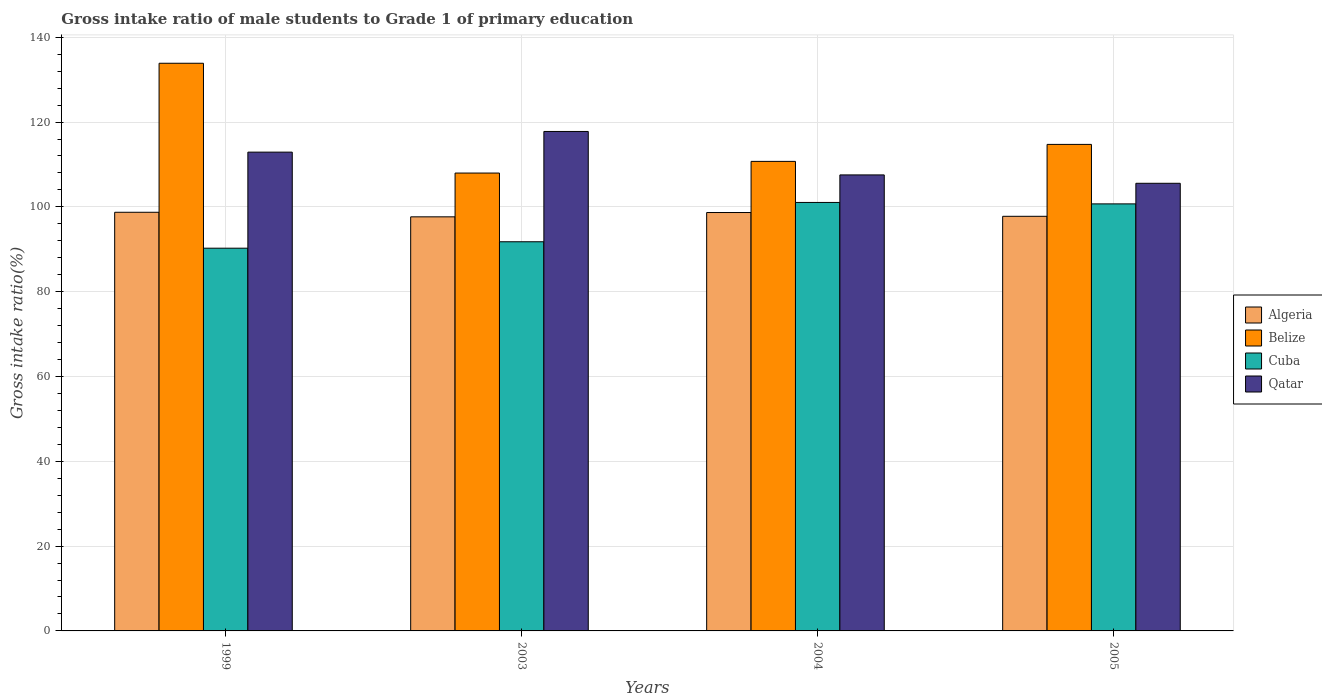Are the number of bars per tick equal to the number of legend labels?
Provide a short and direct response. Yes. Are the number of bars on each tick of the X-axis equal?
Provide a short and direct response. Yes. How many bars are there on the 3rd tick from the right?
Offer a very short reply. 4. In how many cases, is the number of bars for a given year not equal to the number of legend labels?
Your answer should be very brief. 0. What is the gross intake ratio in Belize in 2005?
Your answer should be compact. 114.73. Across all years, what is the maximum gross intake ratio in Cuba?
Offer a terse response. 101.04. Across all years, what is the minimum gross intake ratio in Qatar?
Offer a very short reply. 105.56. In which year was the gross intake ratio in Qatar minimum?
Offer a terse response. 2005. What is the total gross intake ratio in Algeria in the graph?
Make the answer very short. 392.81. What is the difference between the gross intake ratio in Qatar in 1999 and that in 2005?
Your response must be concise. 7.35. What is the difference between the gross intake ratio in Belize in 2003 and the gross intake ratio in Cuba in 2005?
Make the answer very short. 7.27. What is the average gross intake ratio in Belize per year?
Your answer should be very brief. 116.82. In the year 2004, what is the difference between the gross intake ratio in Belize and gross intake ratio in Qatar?
Your answer should be compact. 3.19. What is the ratio of the gross intake ratio in Qatar in 1999 to that in 2005?
Your answer should be compact. 1.07. Is the difference between the gross intake ratio in Belize in 1999 and 2004 greater than the difference between the gross intake ratio in Qatar in 1999 and 2004?
Your response must be concise. Yes. What is the difference between the highest and the second highest gross intake ratio in Cuba?
Make the answer very short. 0.34. What is the difference between the highest and the lowest gross intake ratio in Algeria?
Your answer should be very brief. 1.08. In how many years, is the gross intake ratio in Cuba greater than the average gross intake ratio in Cuba taken over all years?
Offer a terse response. 2. What does the 1st bar from the left in 2004 represents?
Your answer should be very brief. Algeria. What does the 4th bar from the right in 2003 represents?
Ensure brevity in your answer.  Algeria. How many bars are there?
Your response must be concise. 16. Are all the bars in the graph horizontal?
Provide a short and direct response. No. How many years are there in the graph?
Give a very brief answer. 4. What is the difference between two consecutive major ticks on the Y-axis?
Your answer should be compact. 20. Are the values on the major ticks of Y-axis written in scientific E-notation?
Give a very brief answer. No. Does the graph contain grids?
Give a very brief answer. Yes. What is the title of the graph?
Ensure brevity in your answer.  Gross intake ratio of male students to Grade 1 of primary education. What is the label or title of the Y-axis?
Your answer should be very brief. Gross intake ratio(%). What is the Gross intake ratio(%) of Algeria in 1999?
Keep it short and to the point. 98.72. What is the Gross intake ratio(%) in Belize in 1999?
Offer a terse response. 133.86. What is the Gross intake ratio(%) in Cuba in 1999?
Your answer should be very brief. 90.25. What is the Gross intake ratio(%) in Qatar in 1999?
Give a very brief answer. 112.9. What is the Gross intake ratio(%) of Algeria in 2003?
Your response must be concise. 97.65. What is the Gross intake ratio(%) of Belize in 2003?
Ensure brevity in your answer.  107.97. What is the Gross intake ratio(%) of Cuba in 2003?
Your answer should be very brief. 91.77. What is the Gross intake ratio(%) in Qatar in 2003?
Keep it short and to the point. 117.78. What is the Gross intake ratio(%) in Algeria in 2004?
Provide a short and direct response. 98.66. What is the Gross intake ratio(%) of Belize in 2004?
Make the answer very short. 110.72. What is the Gross intake ratio(%) in Cuba in 2004?
Provide a short and direct response. 101.04. What is the Gross intake ratio(%) of Qatar in 2004?
Keep it short and to the point. 107.53. What is the Gross intake ratio(%) of Algeria in 2005?
Your response must be concise. 97.77. What is the Gross intake ratio(%) of Belize in 2005?
Offer a very short reply. 114.73. What is the Gross intake ratio(%) of Cuba in 2005?
Give a very brief answer. 100.7. What is the Gross intake ratio(%) in Qatar in 2005?
Offer a very short reply. 105.56. Across all years, what is the maximum Gross intake ratio(%) in Algeria?
Provide a succinct answer. 98.72. Across all years, what is the maximum Gross intake ratio(%) in Belize?
Offer a very short reply. 133.86. Across all years, what is the maximum Gross intake ratio(%) in Cuba?
Provide a short and direct response. 101.04. Across all years, what is the maximum Gross intake ratio(%) in Qatar?
Your answer should be very brief. 117.78. Across all years, what is the minimum Gross intake ratio(%) of Algeria?
Offer a terse response. 97.65. Across all years, what is the minimum Gross intake ratio(%) of Belize?
Give a very brief answer. 107.97. Across all years, what is the minimum Gross intake ratio(%) of Cuba?
Your answer should be very brief. 90.25. Across all years, what is the minimum Gross intake ratio(%) of Qatar?
Offer a terse response. 105.56. What is the total Gross intake ratio(%) of Algeria in the graph?
Keep it short and to the point. 392.81. What is the total Gross intake ratio(%) of Belize in the graph?
Provide a short and direct response. 467.29. What is the total Gross intake ratio(%) in Cuba in the graph?
Keep it short and to the point. 383.77. What is the total Gross intake ratio(%) of Qatar in the graph?
Give a very brief answer. 443.78. What is the difference between the Gross intake ratio(%) in Algeria in 1999 and that in 2003?
Offer a terse response. 1.08. What is the difference between the Gross intake ratio(%) in Belize in 1999 and that in 2003?
Provide a short and direct response. 25.89. What is the difference between the Gross intake ratio(%) of Cuba in 1999 and that in 2003?
Your answer should be compact. -1.52. What is the difference between the Gross intake ratio(%) of Qatar in 1999 and that in 2003?
Offer a very short reply. -4.87. What is the difference between the Gross intake ratio(%) in Algeria in 1999 and that in 2004?
Your answer should be very brief. 0.06. What is the difference between the Gross intake ratio(%) in Belize in 1999 and that in 2004?
Provide a succinct answer. 23.14. What is the difference between the Gross intake ratio(%) in Cuba in 1999 and that in 2004?
Your answer should be very brief. -10.79. What is the difference between the Gross intake ratio(%) of Qatar in 1999 and that in 2004?
Provide a short and direct response. 5.37. What is the difference between the Gross intake ratio(%) in Algeria in 1999 and that in 2005?
Make the answer very short. 0.95. What is the difference between the Gross intake ratio(%) of Belize in 1999 and that in 2005?
Provide a short and direct response. 19.14. What is the difference between the Gross intake ratio(%) of Cuba in 1999 and that in 2005?
Make the answer very short. -10.45. What is the difference between the Gross intake ratio(%) of Qatar in 1999 and that in 2005?
Offer a very short reply. 7.35. What is the difference between the Gross intake ratio(%) of Algeria in 2003 and that in 2004?
Provide a short and direct response. -1.02. What is the difference between the Gross intake ratio(%) in Belize in 2003 and that in 2004?
Your answer should be compact. -2.75. What is the difference between the Gross intake ratio(%) of Cuba in 2003 and that in 2004?
Provide a succinct answer. -9.27. What is the difference between the Gross intake ratio(%) in Qatar in 2003 and that in 2004?
Offer a terse response. 10.24. What is the difference between the Gross intake ratio(%) in Algeria in 2003 and that in 2005?
Ensure brevity in your answer.  -0.13. What is the difference between the Gross intake ratio(%) in Belize in 2003 and that in 2005?
Offer a very short reply. -6.76. What is the difference between the Gross intake ratio(%) of Cuba in 2003 and that in 2005?
Provide a short and direct response. -8.93. What is the difference between the Gross intake ratio(%) in Qatar in 2003 and that in 2005?
Your response must be concise. 12.22. What is the difference between the Gross intake ratio(%) in Algeria in 2004 and that in 2005?
Offer a very short reply. 0.89. What is the difference between the Gross intake ratio(%) in Belize in 2004 and that in 2005?
Keep it short and to the point. -4. What is the difference between the Gross intake ratio(%) of Cuba in 2004 and that in 2005?
Offer a terse response. 0.34. What is the difference between the Gross intake ratio(%) in Qatar in 2004 and that in 2005?
Make the answer very short. 1.98. What is the difference between the Gross intake ratio(%) of Algeria in 1999 and the Gross intake ratio(%) of Belize in 2003?
Keep it short and to the point. -9.25. What is the difference between the Gross intake ratio(%) of Algeria in 1999 and the Gross intake ratio(%) of Cuba in 2003?
Make the answer very short. 6.95. What is the difference between the Gross intake ratio(%) in Algeria in 1999 and the Gross intake ratio(%) in Qatar in 2003?
Make the answer very short. -19.05. What is the difference between the Gross intake ratio(%) of Belize in 1999 and the Gross intake ratio(%) of Cuba in 2003?
Provide a succinct answer. 42.09. What is the difference between the Gross intake ratio(%) of Belize in 1999 and the Gross intake ratio(%) of Qatar in 2003?
Offer a terse response. 16.08. What is the difference between the Gross intake ratio(%) in Cuba in 1999 and the Gross intake ratio(%) in Qatar in 2003?
Make the answer very short. -27.53. What is the difference between the Gross intake ratio(%) of Algeria in 1999 and the Gross intake ratio(%) of Belize in 2004?
Offer a terse response. -12. What is the difference between the Gross intake ratio(%) in Algeria in 1999 and the Gross intake ratio(%) in Cuba in 2004?
Offer a terse response. -2.32. What is the difference between the Gross intake ratio(%) in Algeria in 1999 and the Gross intake ratio(%) in Qatar in 2004?
Your response must be concise. -8.81. What is the difference between the Gross intake ratio(%) in Belize in 1999 and the Gross intake ratio(%) in Cuba in 2004?
Ensure brevity in your answer.  32.82. What is the difference between the Gross intake ratio(%) in Belize in 1999 and the Gross intake ratio(%) in Qatar in 2004?
Keep it short and to the point. 26.33. What is the difference between the Gross intake ratio(%) in Cuba in 1999 and the Gross intake ratio(%) in Qatar in 2004?
Your response must be concise. -17.28. What is the difference between the Gross intake ratio(%) of Algeria in 1999 and the Gross intake ratio(%) of Belize in 2005?
Provide a succinct answer. -16. What is the difference between the Gross intake ratio(%) in Algeria in 1999 and the Gross intake ratio(%) in Cuba in 2005?
Give a very brief answer. -1.98. What is the difference between the Gross intake ratio(%) of Algeria in 1999 and the Gross intake ratio(%) of Qatar in 2005?
Offer a very short reply. -6.83. What is the difference between the Gross intake ratio(%) in Belize in 1999 and the Gross intake ratio(%) in Cuba in 2005?
Give a very brief answer. 33.16. What is the difference between the Gross intake ratio(%) in Belize in 1999 and the Gross intake ratio(%) in Qatar in 2005?
Your response must be concise. 28.31. What is the difference between the Gross intake ratio(%) of Cuba in 1999 and the Gross intake ratio(%) of Qatar in 2005?
Your response must be concise. -15.31. What is the difference between the Gross intake ratio(%) in Algeria in 2003 and the Gross intake ratio(%) in Belize in 2004?
Give a very brief answer. -13.08. What is the difference between the Gross intake ratio(%) of Algeria in 2003 and the Gross intake ratio(%) of Cuba in 2004?
Your response must be concise. -3.39. What is the difference between the Gross intake ratio(%) of Algeria in 2003 and the Gross intake ratio(%) of Qatar in 2004?
Keep it short and to the point. -9.89. What is the difference between the Gross intake ratio(%) in Belize in 2003 and the Gross intake ratio(%) in Cuba in 2004?
Offer a terse response. 6.93. What is the difference between the Gross intake ratio(%) in Belize in 2003 and the Gross intake ratio(%) in Qatar in 2004?
Make the answer very short. 0.44. What is the difference between the Gross intake ratio(%) in Cuba in 2003 and the Gross intake ratio(%) in Qatar in 2004?
Keep it short and to the point. -15.76. What is the difference between the Gross intake ratio(%) of Algeria in 2003 and the Gross intake ratio(%) of Belize in 2005?
Provide a succinct answer. -17.08. What is the difference between the Gross intake ratio(%) in Algeria in 2003 and the Gross intake ratio(%) in Cuba in 2005?
Provide a short and direct response. -3.06. What is the difference between the Gross intake ratio(%) in Algeria in 2003 and the Gross intake ratio(%) in Qatar in 2005?
Keep it short and to the point. -7.91. What is the difference between the Gross intake ratio(%) of Belize in 2003 and the Gross intake ratio(%) of Cuba in 2005?
Provide a succinct answer. 7.27. What is the difference between the Gross intake ratio(%) in Belize in 2003 and the Gross intake ratio(%) in Qatar in 2005?
Keep it short and to the point. 2.41. What is the difference between the Gross intake ratio(%) in Cuba in 2003 and the Gross intake ratio(%) in Qatar in 2005?
Provide a succinct answer. -13.79. What is the difference between the Gross intake ratio(%) in Algeria in 2004 and the Gross intake ratio(%) in Belize in 2005?
Make the answer very short. -16.06. What is the difference between the Gross intake ratio(%) in Algeria in 2004 and the Gross intake ratio(%) in Cuba in 2005?
Give a very brief answer. -2.04. What is the difference between the Gross intake ratio(%) in Algeria in 2004 and the Gross intake ratio(%) in Qatar in 2005?
Keep it short and to the point. -6.89. What is the difference between the Gross intake ratio(%) of Belize in 2004 and the Gross intake ratio(%) of Cuba in 2005?
Offer a very short reply. 10.02. What is the difference between the Gross intake ratio(%) of Belize in 2004 and the Gross intake ratio(%) of Qatar in 2005?
Your response must be concise. 5.17. What is the difference between the Gross intake ratio(%) of Cuba in 2004 and the Gross intake ratio(%) of Qatar in 2005?
Provide a succinct answer. -4.52. What is the average Gross intake ratio(%) of Algeria per year?
Ensure brevity in your answer.  98.2. What is the average Gross intake ratio(%) in Belize per year?
Provide a short and direct response. 116.82. What is the average Gross intake ratio(%) in Cuba per year?
Provide a short and direct response. 95.94. What is the average Gross intake ratio(%) of Qatar per year?
Your answer should be very brief. 110.94. In the year 1999, what is the difference between the Gross intake ratio(%) of Algeria and Gross intake ratio(%) of Belize?
Your answer should be compact. -35.14. In the year 1999, what is the difference between the Gross intake ratio(%) of Algeria and Gross intake ratio(%) of Cuba?
Keep it short and to the point. 8.47. In the year 1999, what is the difference between the Gross intake ratio(%) of Algeria and Gross intake ratio(%) of Qatar?
Your answer should be very brief. -14.18. In the year 1999, what is the difference between the Gross intake ratio(%) in Belize and Gross intake ratio(%) in Cuba?
Your response must be concise. 43.61. In the year 1999, what is the difference between the Gross intake ratio(%) in Belize and Gross intake ratio(%) in Qatar?
Provide a short and direct response. 20.96. In the year 1999, what is the difference between the Gross intake ratio(%) of Cuba and Gross intake ratio(%) of Qatar?
Give a very brief answer. -22.65. In the year 2003, what is the difference between the Gross intake ratio(%) of Algeria and Gross intake ratio(%) of Belize?
Your answer should be very brief. -10.33. In the year 2003, what is the difference between the Gross intake ratio(%) of Algeria and Gross intake ratio(%) of Cuba?
Keep it short and to the point. 5.88. In the year 2003, what is the difference between the Gross intake ratio(%) in Algeria and Gross intake ratio(%) in Qatar?
Keep it short and to the point. -20.13. In the year 2003, what is the difference between the Gross intake ratio(%) of Belize and Gross intake ratio(%) of Cuba?
Keep it short and to the point. 16.2. In the year 2003, what is the difference between the Gross intake ratio(%) of Belize and Gross intake ratio(%) of Qatar?
Offer a terse response. -9.81. In the year 2003, what is the difference between the Gross intake ratio(%) in Cuba and Gross intake ratio(%) in Qatar?
Your response must be concise. -26.01. In the year 2004, what is the difference between the Gross intake ratio(%) of Algeria and Gross intake ratio(%) of Belize?
Ensure brevity in your answer.  -12.06. In the year 2004, what is the difference between the Gross intake ratio(%) of Algeria and Gross intake ratio(%) of Cuba?
Your response must be concise. -2.38. In the year 2004, what is the difference between the Gross intake ratio(%) of Algeria and Gross intake ratio(%) of Qatar?
Your response must be concise. -8.87. In the year 2004, what is the difference between the Gross intake ratio(%) in Belize and Gross intake ratio(%) in Cuba?
Offer a very short reply. 9.68. In the year 2004, what is the difference between the Gross intake ratio(%) of Belize and Gross intake ratio(%) of Qatar?
Ensure brevity in your answer.  3.19. In the year 2004, what is the difference between the Gross intake ratio(%) in Cuba and Gross intake ratio(%) in Qatar?
Provide a short and direct response. -6.49. In the year 2005, what is the difference between the Gross intake ratio(%) in Algeria and Gross intake ratio(%) in Belize?
Provide a succinct answer. -16.95. In the year 2005, what is the difference between the Gross intake ratio(%) of Algeria and Gross intake ratio(%) of Cuba?
Give a very brief answer. -2.93. In the year 2005, what is the difference between the Gross intake ratio(%) of Algeria and Gross intake ratio(%) of Qatar?
Ensure brevity in your answer.  -7.78. In the year 2005, what is the difference between the Gross intake ratio(%) of Belize and Gross intake ratio(%) of Cuba?
Your response must be concise. 14.02. In the year 2005, what is the difference between the Gross intake ratio(%) of Belize and Gross intake ratio(%) of Qatar?
Your answer should be compact. 9.17. In the year 2005, what is the difference between the Gross intake ratio(%) of Cuba and Gross intake ratio(%) of Qatar?
Ensure brevity in your answer.  -4.85. What is the ratio of the Gross intake ratio(%) of Belize in 1999 to that in 2003?
Provide a succinct answer. 1.24. What is the ratio of the Gross intake ratio(%) of Cuba in 1999 to that in 2003?
Ensure brevity in your answer.  0.98. What is the ratio of the Gross intake ratio(%) in Qatar in 1999 to that in 2003?
Give a very brief answer. 0.96. What is the ratio of the Gross intake ratio(%) of Algeria in 1999 to that in 2004?
Keep it short and to the point. 1. What is the ratio of the Gross intake ratio(%) in Belize in 1999 to that in 2004?
Offer a very short reply. 1.21. What is the ratio of the Gross intake ratio(%) of Cuba in 1999 to that in 2004?
Make the answer very short. 0.89. What is the ratio of the Gross intake ratio(%) of Qatar in 1999 to that in 2004?
Your answer should be compact. 1.05. What is the ratio of the Gross intake ratio(%) of Algeria in 1999 to that in 2005?
Give a very brief answer. 1.01. What is the ratio of the Gross intake ratio(%) in Belize in 1999 to that in 2005?
Offer a terse response. 1.17. What is the ratio of the Gross intake ratio(%) of Cuba in 1999 to that in 2005?
Give a very brief answer. 0.9. What is the ratio of the Gross intake ratio(%) in Qatar in 1999 to that in 2005?
Your answer should be compact. 1.07. What is the ratio of the Gross intake ratio(%) of Belize in 2003 to that in 2004?
Offer a terse response. 0.98. What is the ratio of the Gross intake ratio(%) of Cuba in 2003 to that in 2004?
Provide a succinct answer. 0.91. What is the ratio of the Gross intake ratio(%) of Qatar in 2003 to that in 2004?
Your answer should be compact. 1.1. What is the ratio of the Gross intake ratio(%) in Belize in 2003 to that in 2005?
Ensure brevity in your answer.  0.94. What is the ratio of the Gross intake ratio(%) in Cuba in 2003 to that in 2005?
Provide a short and direct response. 0.91. What is the ratio of the Gross intake ratio(%) in Qatar in 2003 to that in 2005?
Offer a very short reply. 1.12. What is the ratio of the Gross intake ratio(%) of Algeria in 2004 to that in 2005?
Your answer should be very brief. 1.01. What is the ratio of the Gross intake ratio(%) of Belize in 2004 to that in 2005?
Offer a terse response. 0.97. What is the ratio of the Gross intake ratio(%) in Cuba in 2004 to that in 2005?
Offer a terse response. 1. What is the ratio of the Gross intake ratio(%) in Qatar in 2004 to that in 2005?
Offer a terse response. 1.02. What is the difference between the highest and the second highest Gross intake ratio(%) in Algeria?
Make the answer very short. 0.06. What is the difference between the highest and the second highest Gross intake ratio(%) in Belize?
Offer a very short reply. 19.14. What is the difference between the highest and the second highest Gross intake ratio(%) of Cuba?
Provide a succinct answer. 0.34. What is the difference between the highest and the second highest Gross intake ratio(%) of Qatar?
Your response must be concise. 4.87. What is the difference between the highest and the lowest Gross intake ratio(%) in Algeria?
Your answer should be very brief. 1.08. What is the difference between the highest and the lowest Gross intake ratio(%) of Belize?
Give a very brief answer. 25.89. What is the difference between the highest and the lowest Gross intake ratio(%) of Cuba?
Your response must be concise. 10.79. What is the difference between the highest and the lowest Gross intake ratio(%) in Qatar?
Offer a very short reply. 12.22. 